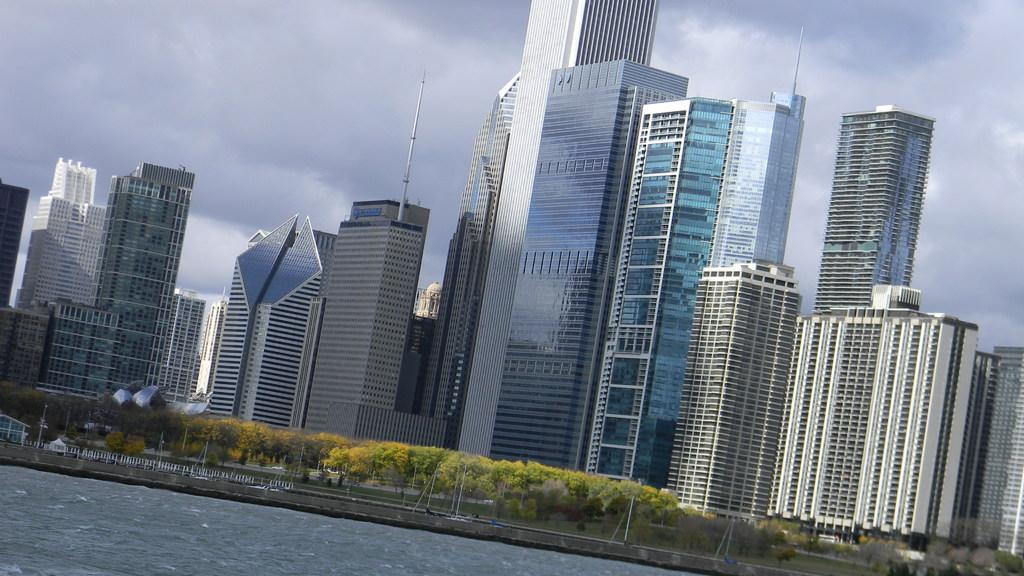What type of structures can be seen in the image? There are buildings in the image. What natural elements are present in the image? There are trees in the image. What man-made objects can be seen in the image? There are poles in the image. What is the water feature in the image? There is water visible in the image. What else can be seen in the image besides the mentioned elements? There are other objects in the image. What is visible in the background of the image? The sky is visible in the background of the image. Can you tell me how many sticks of butter are on the buildings in the image? There is no butter present in the image; it features buildings, trees, poles, water, and other objects. Why are the trees crying in the image? Trees do not have the ability to cry; there are trees present in the image, but they are not depicted as crying. 